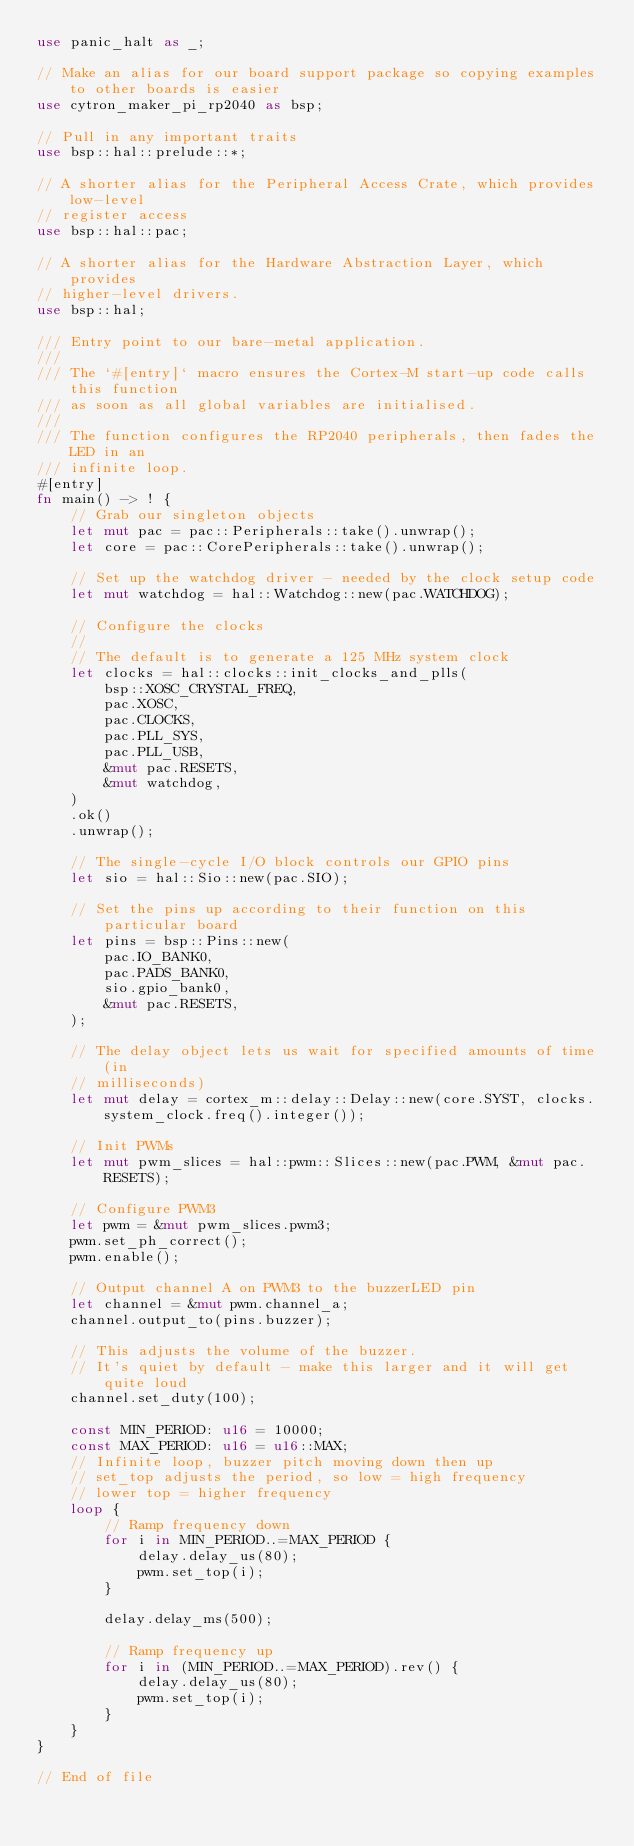<code> <loc_0><loc_0><loc_500><loc_500><_Rust_>use panic_halt as _;

// Make an alias for our board support package so copying examples to other boards is easier
use cytron_maker_pi_rp2040 as bsp;

// Pull in any important traits
use bsp::hal::prelude::*;

// A shorter alias for the Peripheral Access Crate, which provides low-level
// register access
use bsp::hal::pac;

// A shorter alias for the Hardware Abstraction Layer, which provides
// higher-level drivers.
use bsp::hal;

/// Entry point to our bare-metal application.
///
/// The `#[entry]` macro ensures the Cortex-M start-up code calls this function
/// as soon as all global variables are initialised.
///
/// The function configures the RP2040 peripherals, then fades the LED in an
/// infinite loop.
#[entry]
fn main() -> ! {
    // Grab our singleton objects
    let mut pac = pac::Peripherals::take().unwrap();
    let core = pac::CorePeripherals::take().unwrap();

    // Set up the watchdog driver - needed by the clock setup code
    let mut watchdog = hal::Watchdog::new(pac.WATCHDOG);

    // Configure the clocks
    //
    // The default is to generate a 125 MHz system clock
    let clocks = hal::clocks::init_clocks_and_plls(
        bsp::XOSC_CRYSTAL_FREQ,
        pac.XOSC,
        pac.CLOCKS,
        pac.PLL_SYS,
        pac.PLL_USB,
        &mut pac.RESETS,
        &mut watchdog,
    )
    .ok()
    .unwrap();

    // The single-cycle I/O block controls our GPIO pins
    let sio = hal::Sio::new(pac.SIO);

    // Set the pins up according to their function on this particular board
    let pins = bsp::Pins::new(
        pac.IO_BANK0,
        pac.PADS_BANK0,
        sio.gpio_bank0,
        &mut pac.RESETS,
    );

    // The delay object lets us wait for specified amounts of time (in
    // milliseconds)
    let mut delay = cortex_m::delay::Delay::new(core.SYST, clocks.system_clock.freq().integer());

    // Init PWMs
    let mut pwm_slices = hal::pwm::Slices::new(pac.PWM, &mut pac.RESETS);

    // Configure PWM3
    let pwm = &mut pwm_slices.pwm3;
    pwm.set_ph_correct();
    pwm.enable();

    // Output channel A on PWM3 to the buzzerLED pin
    let channel = &mut pwm.channel_a;
    channel.output_to(pins.buzzer);

    // This adjusts the volume of the buzzer.
    // It's quiet by default - make this larger and it will get quite loud
    channel.set_duty(100);

    const MIN_PERIOD: u16 = 10000;
    const MAX_PERIOD: u16 = u16::MAX;
    // Infinite loop, buzzer pitch moving down then up
    // set_top adjusts the period, so low = high frequency
    // lower top = higher frequency
    loop {
        // Ramp frequency down
        for i in MIN_PERIOD..=MAX_PERIOD {
            delay.delay_us(80);
            pwm.set_top(i);
        }

        delay.delay_ms(500);

        // Ramp frequency up
        for i in (MIN_PERIOD..=MAX_PERIOD).rev() {
            delay.delay_us(80);
            pwm.set_top(i);
        }
    }
}

// End of file
</code> 